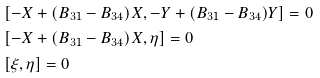Convert formula to latex. <formula><loc_0><loc_0><loc_500><loc_500>& \left [ - X + ( B _ { 3 1 } - B _ { 3 4 } ) X , - Y + ( B _ { 3 1 } - B _ { 3 4 } ) Y \right ] = 0 \\ & \left [ - X + ( B _ { 3 1 } - B _ { 3 4 } ) X , \eta \right ] = 0 \\ & \left [ \xi , \eta \right ] = 0</formula> 